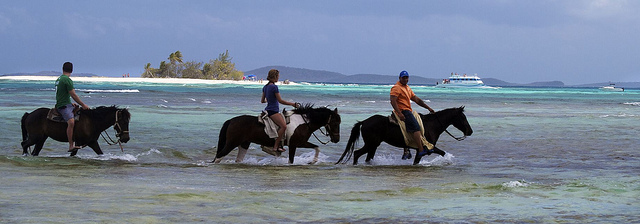Can you tell me about the weather conditions? The weather conditions seem ideal for outdoor activities, with a clear sky and ample sunshine, making for a splendid day at the beach. The sunlight enhances the vibrant colors of the sea and landscape. 